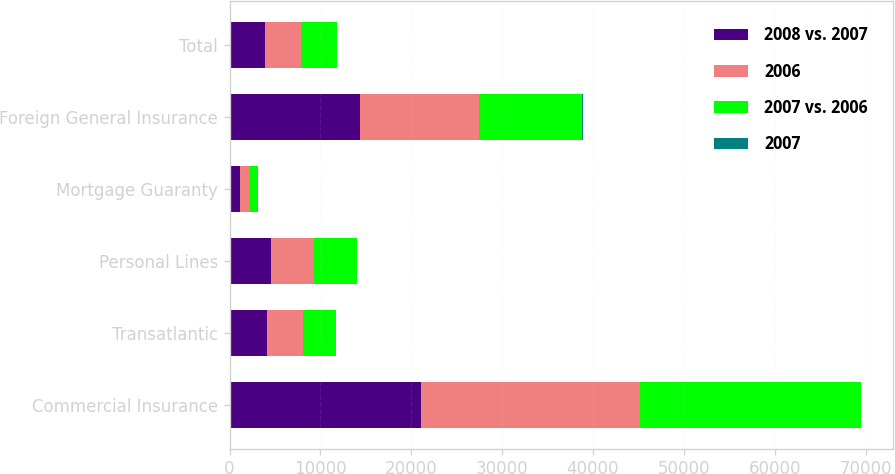Convert chart to OTSL. <chart><loc_0><loc_0><loc_500><loc_500><stacked_bar_chart><ecel><fcel>Commercial Insurance<fcel>Transatlantic<fcel>Personal Lines<fcel>Mortgage Guaranty<fcel>Foreign General Insurance<fcel>Total<nl><fcel>2008 vs. 2007<fcel>21099<fcel>4108<fcel>4514<fcel>1123<fcel>14390<fcel>3953<nl><fcel>2006<fcel>24112<fcel>3953<fcel>4808<fcel>1143<fcel>13051<fcel>3953<nl><fcel>2007 vs. 2006<fcel>24312<fcel>3633<fcel>4654<fcel>866<fcel>11401<fcel>3953<nl><fcel>2007<fcel>12<fcel>4<fcel>6<fcel>2<fcel>10<fcel>4<nl></chart> 